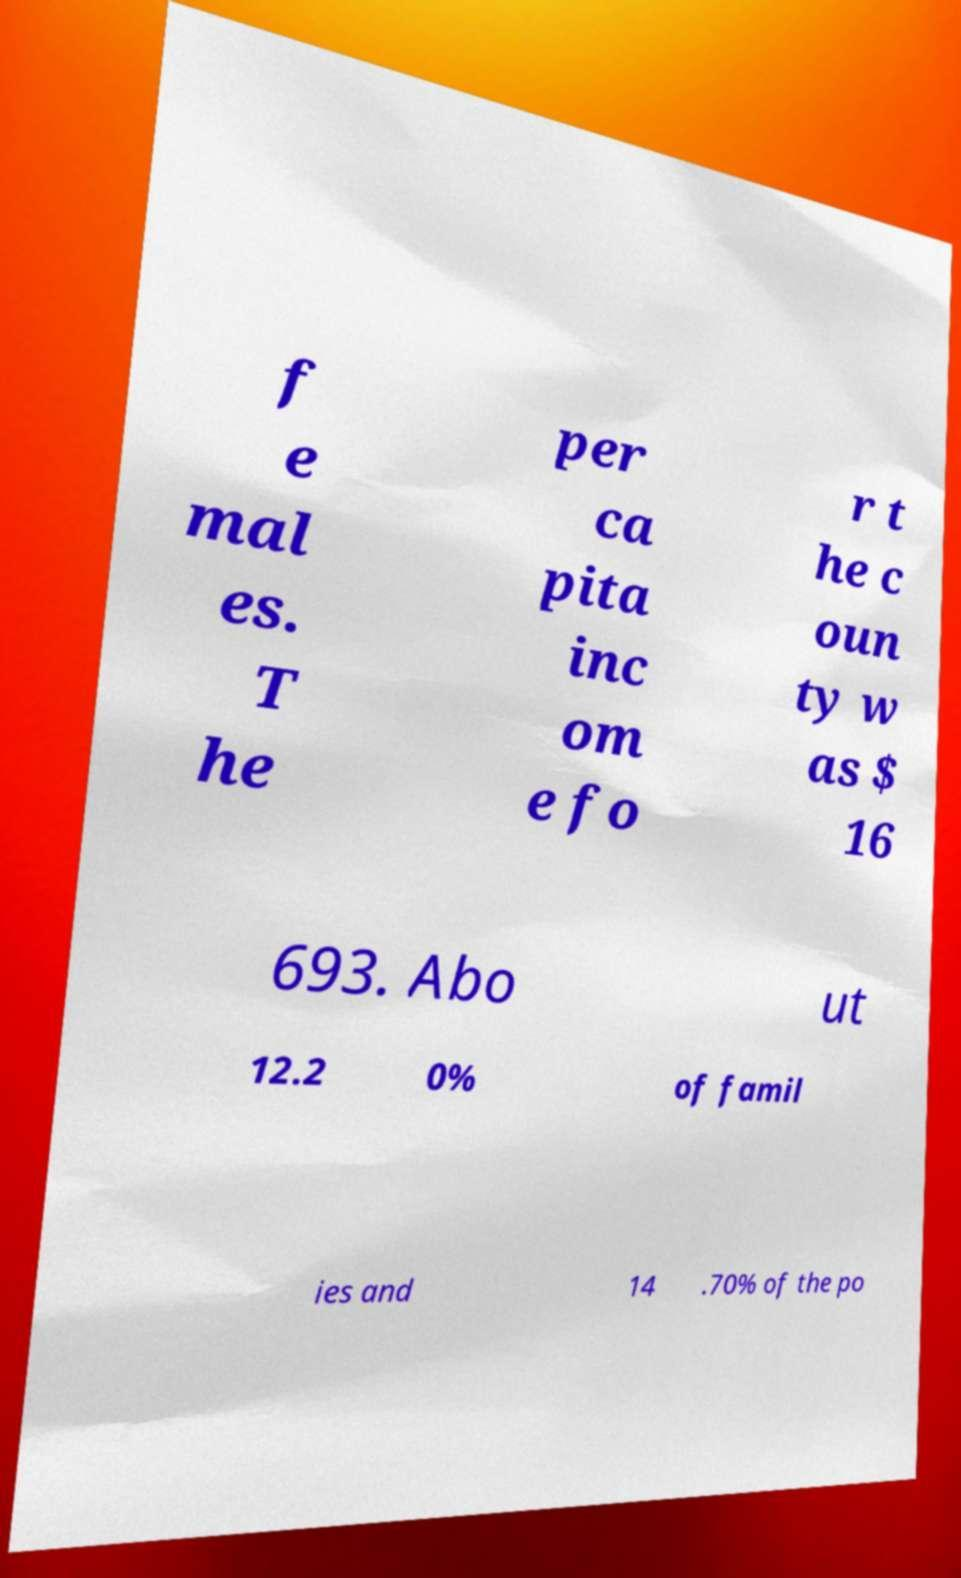Could you assist in decoding the text presented in this image and type it out clearly? f e mal es. T he per ca pita inc om e fo r t he c oun ty w as $ 16 693. Abo ut 12.2 0% of famil ies and 14 .70% of the po 